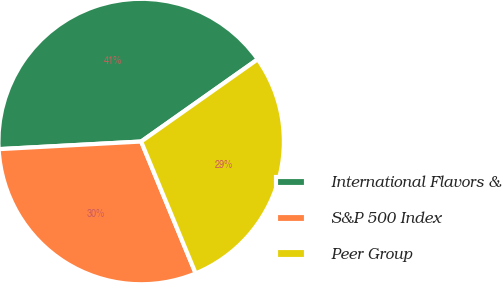Convert chart. <chart><loc_0><loc_0><loc_500><loc_500><pie_chart><fcel>International Flavors &<fcel>S&P 500 Index<fcel>Peer Group<nl><fcel>41.07%<fcel>30.39%<fcel>28.54%<nl></chart> 